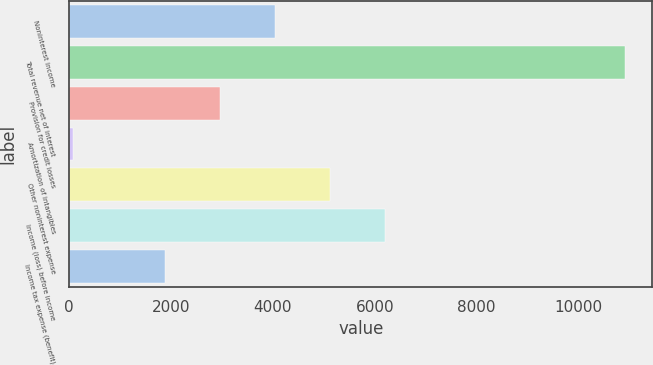<chart> <loc_0><loc_0><loc_500><loc_500><bar_chart><fcel>Noninterest income<fcel>Total revenue net of interest<fcel>Provision for credit losses<fcel>Amortization of intangibles<fcel>Other noninterest expense<fcel>Income (loss) before income<fcel>Income tax expense (benefit)<nl><fcel>4043.2<fcel>10903<fcel>2960.1<fcel>72<fcel>5126.3<fcel>6209.4<fcel>1877<nl></chart> 